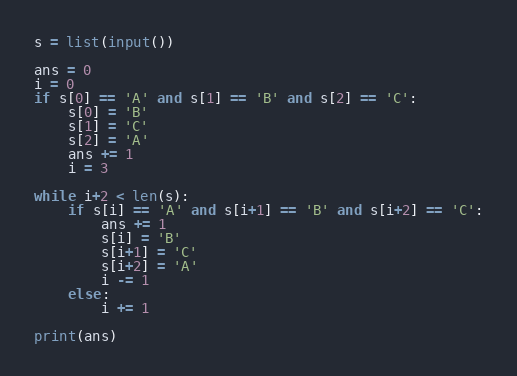<code> <loc_0><loc_0><loc_500><loc_500><_Python_>s = list(input())

ans = 0
i = 0
if s[0] == 'A' and s[1] == 'B' and s[2] == 'C':
    s[0] = 'B'
    s[1] = 'C'
    s[2] = 'A'
    ans += 1
    i = 3

while i+2 < len(s):
    if s[i] == 'A' and s[i+1] == 'B' and s[i+2] == 'C':
        ans += 1
        s[i] = 'B'
        s[i+1] = 'C'
        s[i+2] = 'A'
        i -= 1
    else:
        i += 1

print(ans)</code> 